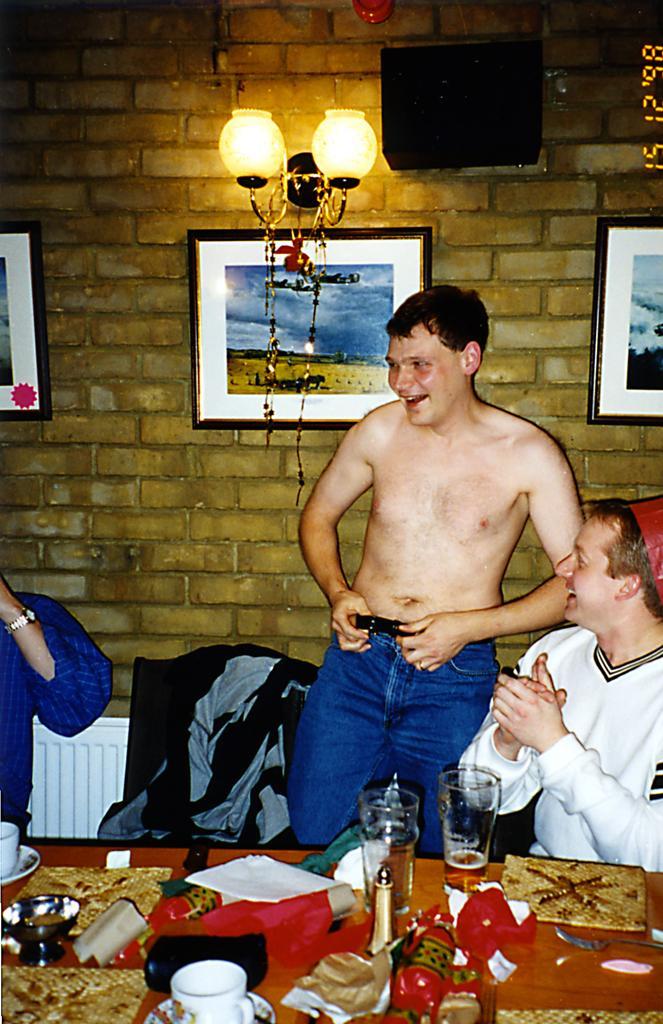How would you summarize this image in a sentence or two? In this image we can see some people. In that a man is standing holding a belt. We can also see a table beside them containing some bowls, a cup with a saucer, papers, bottles, a fork and some glasses with beer. On the backside we can see some photo frames and a lamp hanged to the wall. 